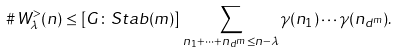Convert formula to latex. <formula><loc_0><loc_0><loc_500><loc_500>\# \, W _ { \lambda } ^ { > } ( n ) & \leq [ G \colon S t a b ( m ) ] \, \sum _ { n _ { 1 } + \dots + n _ { d ^ { m } } \leq n - \lambda } \gamma ( n _ { 1 } ) \cdots \gamma ( n _ { d ^ { m } } ) .</formula> 